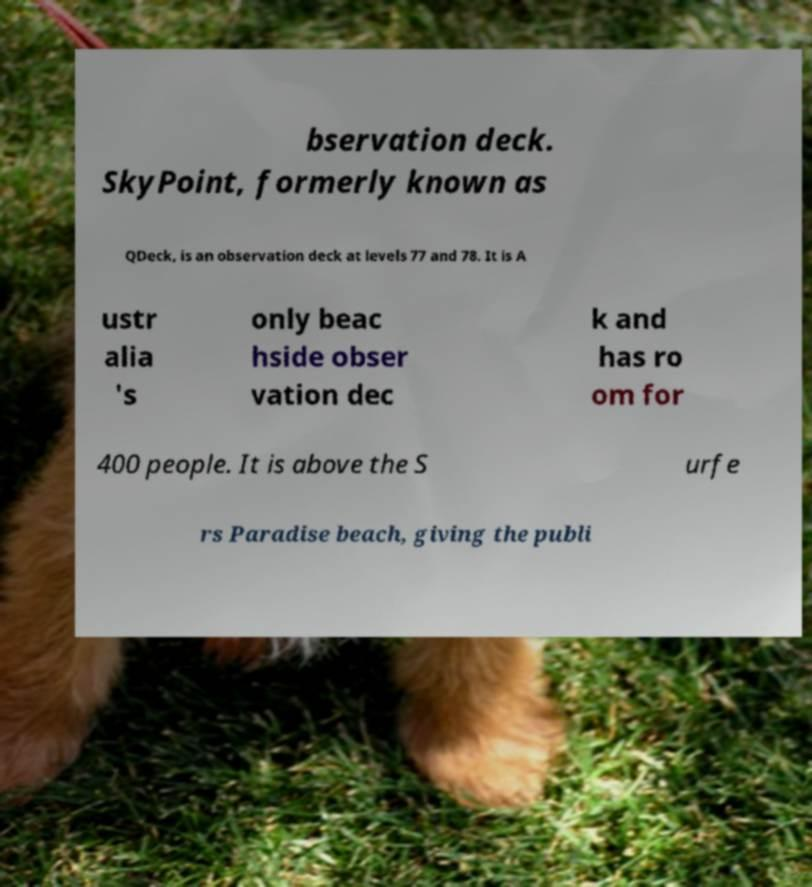Could you extract and type out the text from this image? bservation deck. SkyPoint, formerly known as QDeck, is an observation deck at levels 77 and 78. It is A ustr alia 's only beac hside obser vation dec k and has ro om for 400 people. It is above the S urfe rs Paradise beach, giving the publi 